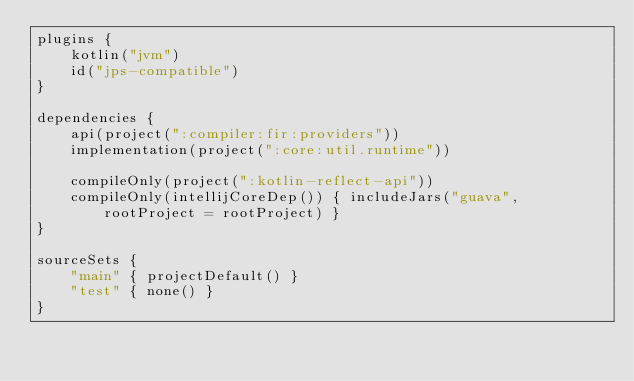Convert code to text. <code><loc_0><loc_0><loc_500><loc_500><_Kotlin_>plugins {
    kotlin("jvm")
    id("jps-compatible")
}

dependencies {
    api(project(":compiler:fir:providers"))
    implementation(project(":core:util.runtime"))

    compileOnly(project(":kotlin-reflect-api"))
    compileOnly(intellijCoreDep()) { includeJars("guava", rootProject = rootProject) }
}

sourceSets {
    "main" { projectDefault() }
    "test" { none() }
}
</code> 